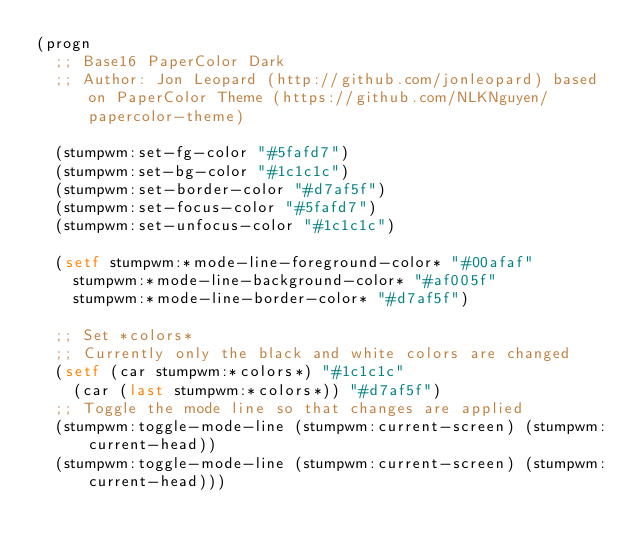Convert code to text. <code><loc_0><loc_0><loc_500><loc_500><_Lisp_>(progn
  ;; Base16 PaperColor Dark
  ;; Author: Jon Leopard (http://github.com/jonleopard) based on PaperColor Theme (https://github.com/NLKNguyen/papercolor-theme)

  (stumpwm:set-fg-color "#5fafd7")
  (stumpwm:set-bg-color "#1c1c1c")
  (stumpwm:set-border-color "#d7af5f")
  (stumpwm:set-focus-color "#5fafd7")
  (stumpwm:set-unfocus-color "#1c1c1c")

  (setf stumpwm:*mode-line-foreground-color* "#00afaf"
	stumpwm:*mode-line-background-color* "#af005f"
	stumpwm:*mode-line-border-color* "#d7af5f")

  ;; Set *colors*
  ;; Currently only the black and white colors are changed
  (setf (car stumpwm:*colors*) "#1c1c1c"
	(car (last stumpwm:*colors*)) "#d7af5f")
  ;; Toggle the mode line so that changes are applied
  (stumpwm:toggle-mode-line (stumpwm:current-screen) (stumpwm:current-head))
  (stumpwm:toggle-mode-line (stumpwm:current-screen) (stumpwm:current-head)))
       
</code> 